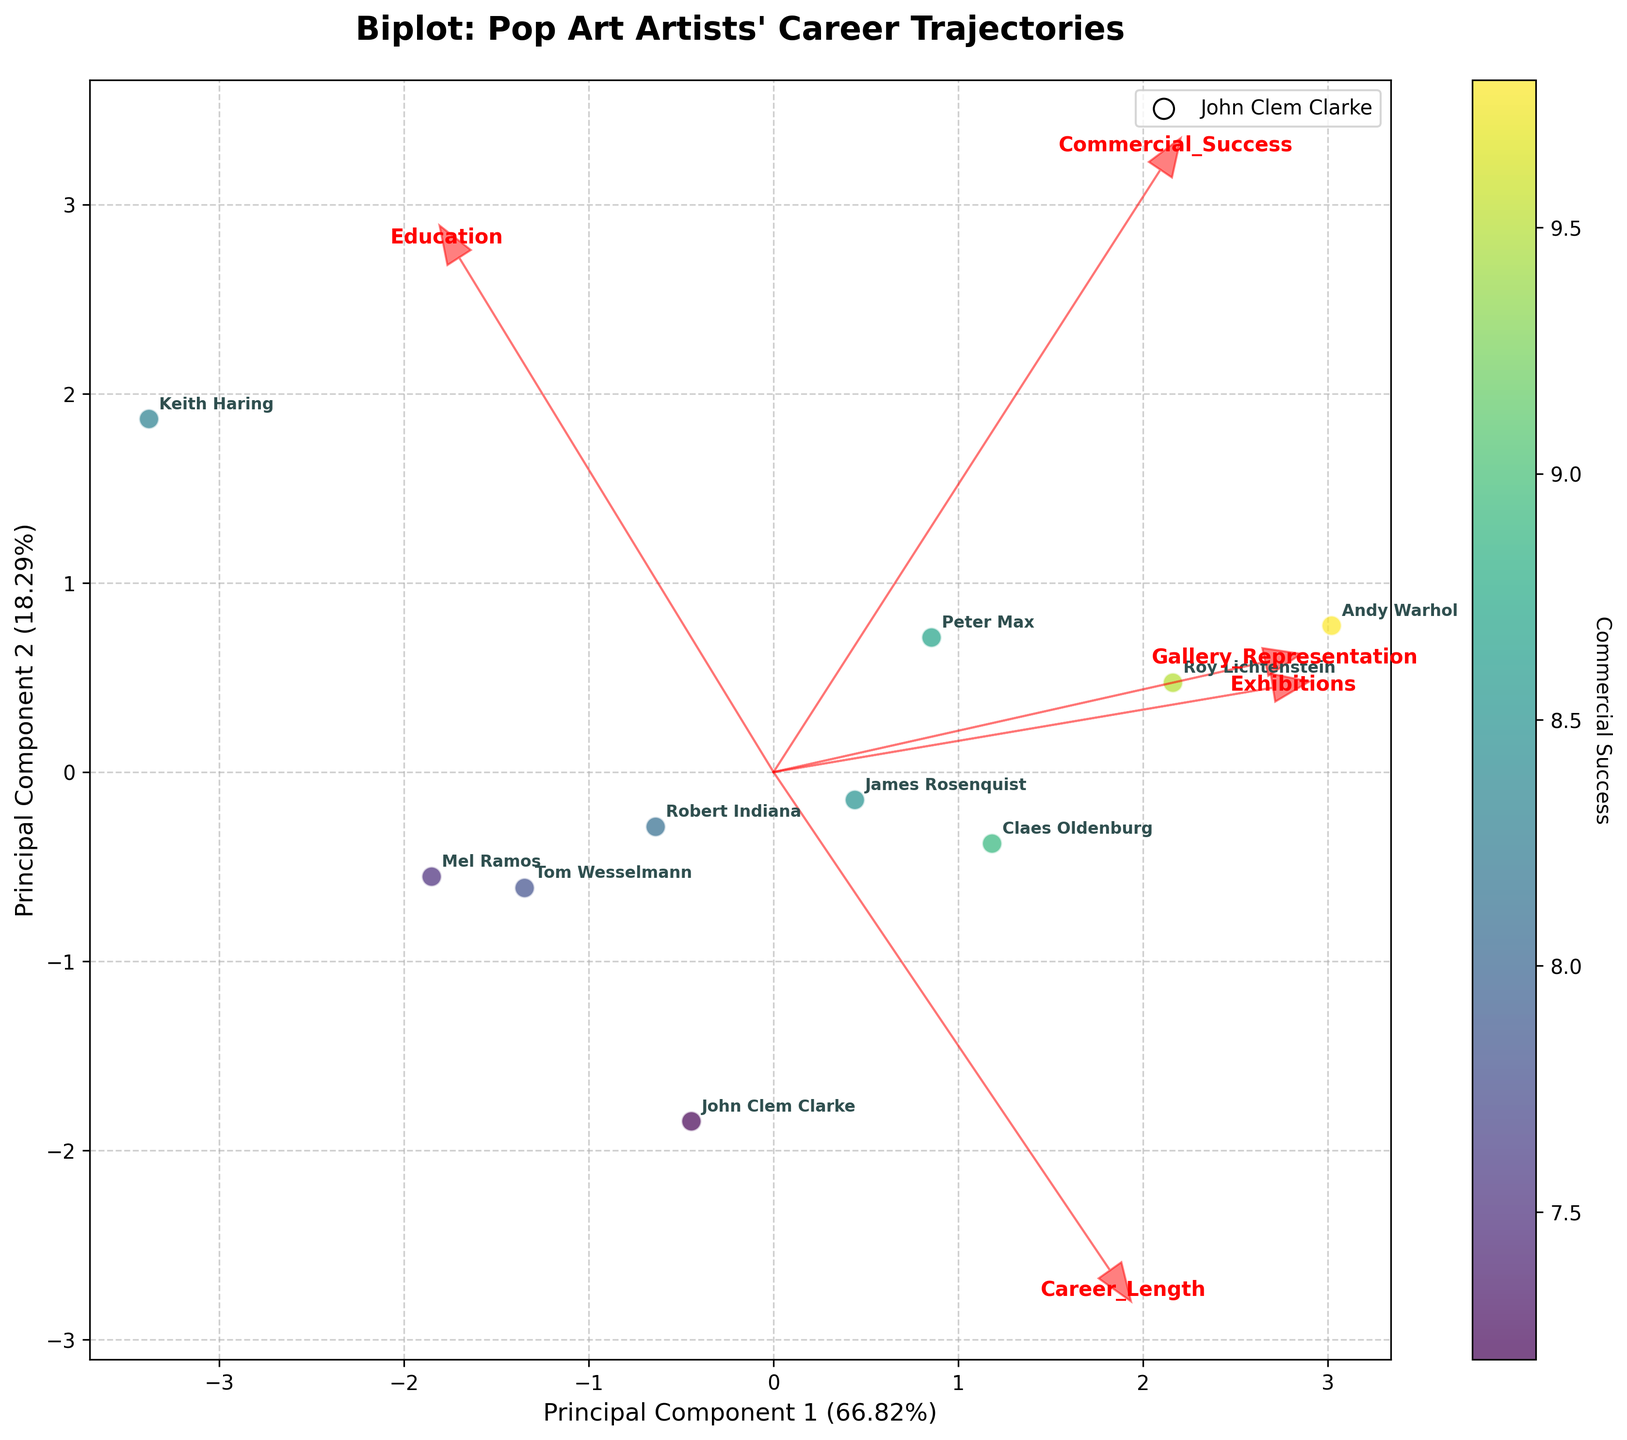Which artist has the highest Commercial Success score? The colorbar indicates Commercial Success scores with a range from 4 to 10. Andy Warhol, marked with 'Warhol' in dark color, is separated from the rest with the highest score.
Answer: Andy Warhol How many artists are represented by more than 7 galleries? Observing the plot, the Gallery_Representation axis has arrows. Count the artists positioned positively along this axis. There are 5 artists: Andy Warhol, Roy Lichtenstein, Peter Max, James Rosenquist, and Claes Oldenburg.
Answer: 5 How does John Clem Clarke's Exhibition frequency compare to Andy Warhol's? Clarke has 85 exhibitions, and Warhol has 120 exhibitions as seen by their annotated names on the plot. Comparing these values visually shows that Warhol's frequency is higher.
Answer: Warhol has more Is there any artist whose Career Length is positively correlated with their Gallery Representation? The arrow directions of Career_Length and Gallery_Representation axes show a somewhat similar direction indicating a positive correlation. Artists like Andy Warhol and Roy Lichtenstein feature at positive ends of both axes.
Answer: Yes Which feature has the least impact on Principal Component 2 (PC2)? The length of arrows along PC2 helps see contributions. The Gallery_Representation arrow is the shortest along PC2, thus least impacting it.
Answer: Gallery Representation What is the relationship between Education and Commercial Success? The arrow direction of Education and Commercial_Success components show opposite directions indicating a negative correlation. Higher education seems less aligned with Commercial Success.
Answer: Negative correlation Who has a shorter Career Length but higher Commercial Success compared to Claes Oldenburg? Claes Oldenburg has a long Career Length and moderately high Commercial Success. Keith Haring, with a shorter Career Length (10 years) but relatively high Commercial Success (over 8.3), fits these criteria.
Answer: Keith Haring Which artist has the highest number of Exhibitions beyond 100 exhibits? From the data plot, Andy Warhol and Roy Lichtenstein are placed in high exhibit count zones, with Andy Warhol having 120 the highest number of exhibitions.
Answer: Andy Warhol Which feature plays the most significant role in Principal Component 1 (PC1)? Examining the length of feature arrows along PC1, Commercial_Success arrow is the longest indicating its significant contribution to PC1.
Answer: Commercial Success 